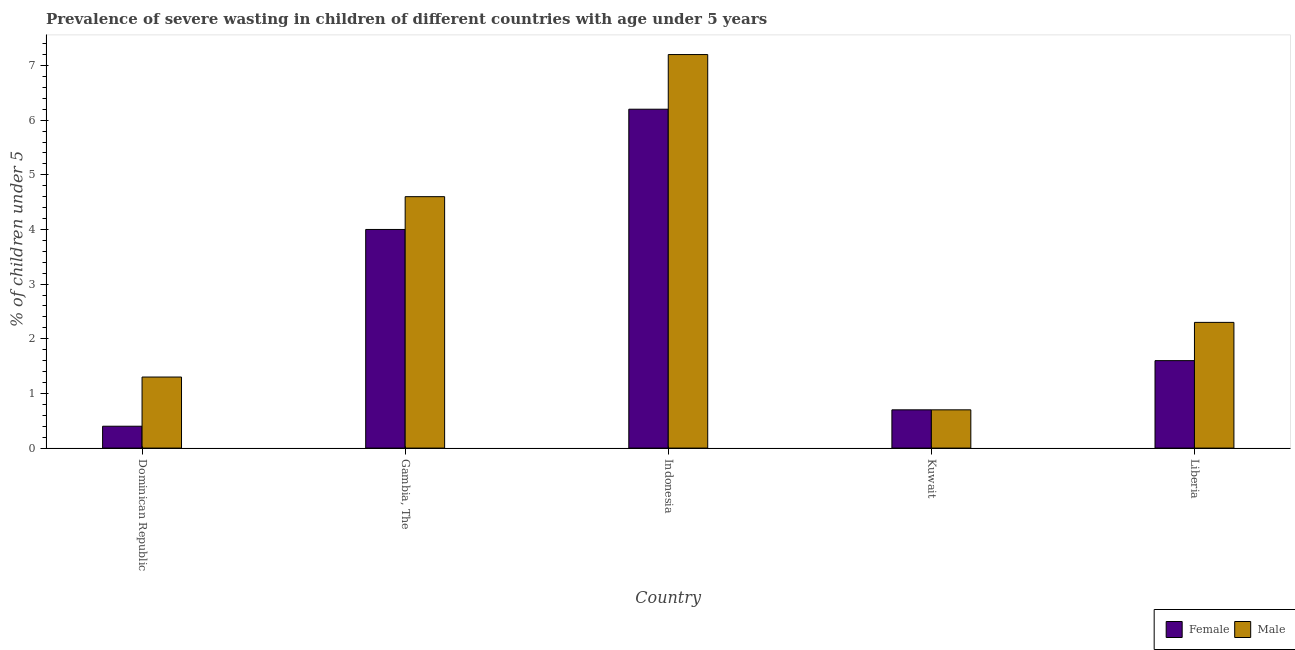How many different coloured bars are there?
Provide a succinct answer. 2. How many groups of bars are there?
Make the answer very short. 5. How many bars are there on the 1st tick from the left?
Your answer should be very brief. 2. How many bars are there on the 1st tick from the right?
Make the answer very short. 2. What is the label of the 4th group of bars from the left?
Offer a very short reply. Kuwait. What is the percentage of undernourished female children in Gambia, The?
Your answer should be compact. 4. Across all countries, what is the maximum percentage of undernourished male children?
Your answer should be very brief. 7.2. Across all countries, what is the minimum percentage of undernourished male children?
Provide a succinct answer. 0.7. In which country was the percentage of undernourished male children maximum?
Your response must be concise. Indonesia. In which country was the percentage of undernourished male children minimum?
Your answer should be compact. Kuwait. What is the total percentage of undernourished female children in the graph?
Your answer should be compact. 12.9. What is the difference between the percentage of undernourished female children in Indonesia and that in Liberia?
Your response must be concise. 4.6. What is the difference between the percentage of undernourished female children in Gambia, The and the percentage of undernourished male children in Indonesia?
Ensure brevity in your answer.  -3.2. What is the average percentage of undernourished female children per country?
Provide a short and direct response. 2.58. What is the difference between the percentage of undernourished female children and percentage of undernourished male children in Gambia, The?
Offer a very short reply. -0.6. What is the ratio of the percentage of undernourished female children in Dominican Republic to that in Indonesia?
Ensure brevity in your answer.  0.06. Is the percentage of undernourished male children in Dominican Republic less than that in Gambia, The?
Offer a terse response. Yes. What is the difference between the highest and the second highest percentage of undernourished female children?
Provide a succinct answer. 2.2. What is the difference between the highest and the lowest percentage of undernourished female children?
Your answer should be very brief. 5.8. In how many countries, is the percentage of undernourished female children greater than the average percentage of undernourished female children taken over all countries?
Offer a very short reply. 2. What does the 2nd bar from the left in Gambia, The represents?
Give a very brief answer. Male. What does the 2nd bar from the right in Dominican Republic represents?
Make the answer very short. Female. Are all the bars in the graph horizontal?
Provide a short and direct response. No. How many countries are there in the graph?
Offer a terse response. 5. What is the difference between two consecutive major ticks on the Y-axis?
Make the answer very short. 1. Does the graph contain grids?
Your answer should be very brief. No. How many legend labels are there?
Make the answer very short. 2. How are the legend labels stacked?
Provide a succinct answer. Horizontal. What is the title of the graph?
Provide a short and direct response. Prevalence of severe wasting in children of different countries with age under 5 years. What is the label or title of the Y-axis?
Your answer should be compact.  % of children under 5. What is the  % of children under 5 in Female in Dominican Republic?
Your answer should be compact. 0.4. What is the  % of children under 5 of Male in Dominican Republic?
Your answer should be very brief. 1.3. What is the  % of children under 5 in Female in Gambia, The?
Keep it short and to the point. 4. What is the  % of children under 5 in Male in Gambia, The?
Make the answer very short. 4.6. What is the  % of children under 5 in Female in Indonesia?
Your response must be concise. 6.2. What is the  % of children under 5 in Male in Indonesia?
Your answer should be very brief. 7.2. What is the  % of children under 5 in Female in Kuwait?
Offer a very short reply. 0.7. What is the  % of children under 5 of Male in Kuwait?
Ensure brevity in your answer.  0.7. What is the  % of children under 5 of Female in Liberia?
Ensure brevity in your answer.  1.6. What is the  % of children under 5 in Male in Liberia?
Make the answer very short. 2.3. Across all countries, what is the maximum  % of children under 5 in Female?
Give a very brief answer. 6.2. Across all countries, what is the maximum  % of children under 5 in Male?
Your response must be concise. 7.2. Across all countries, what is the minimum  % of children under 5 in Female?
Give a very brief answer. 0.4. Across all countries, what is the minimum  % of children under 5 of Male?
Your response must be concise. 0.7. What is the total  % of children under 5 in Male in the graph?
Your answer should be very brief. 16.1. What is the difference between the  % of children under 5 of Male in Dominican Republic and that in Gambia, The?
Offer a terse response. -3.3. What is the difference between the  % of children under 5 in Male in Gambia, The and that in Kuwait?
Provide a short and direct response. 3.9. What is the difference between the  % of children under 5 of Female in Gambia, The and that in Liberia?
Your answer should be compact. 2.4. What is the difference between the  % of children under 5 of Female in Indonesia and that in Kuwait?
Your answer should be very brief. 5.5. What is the difference between the  % of children under 5 in Male in Indonesia and that in Kuwait?
Ensure brevity in your answer.  6.5. What is the difference between the  % of children under 5 in Female in Indonesia and that in Liberia?
Ensure brevity in your answer.  4.6. What is the difference between the  % of children under 5 in Female in Kuwait and that in Liberia?
Your answer should be compact. -0.9. What is the difference between the  % of children under 5 of Male in Kuwait and that in Liberia?
Your answer should be very brief. -1.6. What is the difference between the  % of children under 5 in Female in Dominican Republic and the  % of children under 5 in Male in Kuwait?
Offer a terse response. -0.3. What is the difference between the  % of children under 5 of Female in Dominican Republic and the  % of children under 5 of Male in Liberia?
Your response must be concise. -1.9. What is the difference between the  % of children under 5 in Female in Gambia, The and the  % of children under 5 in Male in Kuwait?
Provide a short and direct response. 3.3. What is the difference between the  % of children under 5 in Female in Gambia, The and the  % of children under 5 in Male in Liberia?
Make the answer very short. 1.7. What is the difference between the  % of children under 5 of Female in Kuwait and the  % of children under 5 of Male in Liberia?
Offer a terse response. -1.6. What is the average  % of children under 5 of Female per country?
Provide a succinct answer. 2.58. What is the average  % of children under 5 of Male per country?
Provide a succinct answer. 3.22. What is the difference between the  % of children under 5 of Female and  % of children under 5 of Male in Indonesia?
Keep it short and to the point. -1. What is the difference between the  % of children under 5 of Female and  % of children under 5 of Male in Kuwait?
Keep it short and to the point. 0. What is the difference between the  % of children under 5 in Female and  % of children under 5 in Male in Liberia?
Offer a terse response. -0.7. What is the ratio of the  % of children under 5 in Male in Dominican Republic to that in Gambia, The?
Provide a succinct answer. 0.28. What is the ratio of the  % of children under 5 of Female in Dominican Republic to that in Indonesia?
Give a very brief answer. 0.06. What is the ratio of the  % of children under 5 of Male in Dominican Republic to that in Indonesia?
Your response must be concise. 0.18. What is the ratio of the  % of children under 5 of Female in Dominican Republic to that in Kuwait?
Keep it short and to the point. 0.57. What is the ratio of the  % of children under 5 of Male in Dominican Republic to that in Kuwait?
Keep it short and to the point. 1.86. What is the ratio of the  % of children under 5 of Male in Dominican Republic to that in Liberia?
Keep it short and to the point. 0.57. What is the ratio of the  % of children under 5 in Female in Gambia, The to that in Indonesia?
Your answer should be compact. 0.65. What is the ratio of the  % of children under 5 of Male in Gambia, The to that in Indonesia?
Provide a short and direct response. 0.64. What is the ratio of the  % of children under 5 in Female in Gambia, The to that in Kuwait?
Offer a very short reply. 5.71. What is the ratio of the  % of children under 5 in Male in Gambia, The to that in Kuwait?
Ensure brevity in your answer.  6.57. What is the ratio of the  % of children under 5 in Female in Indonesia to that in Kuwait?
Offer a terse response. 8.86. What is the ratio of the  % of children under 5 in Male in Indonesia to that in Kuwait?
Make the answer very short. 10.29. What is the ratio of the  % of children under 5 of Female in Indonesia to that in Liberia?
Your response must be concise. 3.88. What is the ratio of the  % of children under 5 of Male in Indonesia to that in Liberia?
Give a very brief answer. 3.13. What is the ratio of the  % of children under 5 in Female in Kuwait to that in Liberia?
Provide a short and direct response. 0.44. What is the ratio of the  % of children under 5 in Male in Kuwait to that in Liberia?
Give a very brief answer. 0.3. What is the difference between the highest and the lowest  % of children under 5 of Female?
Provide a short and direct response. 5.8. What is the difference between the highest and the lowest  % of children under 5 of Male?
Your response must be concise. 6.5. 